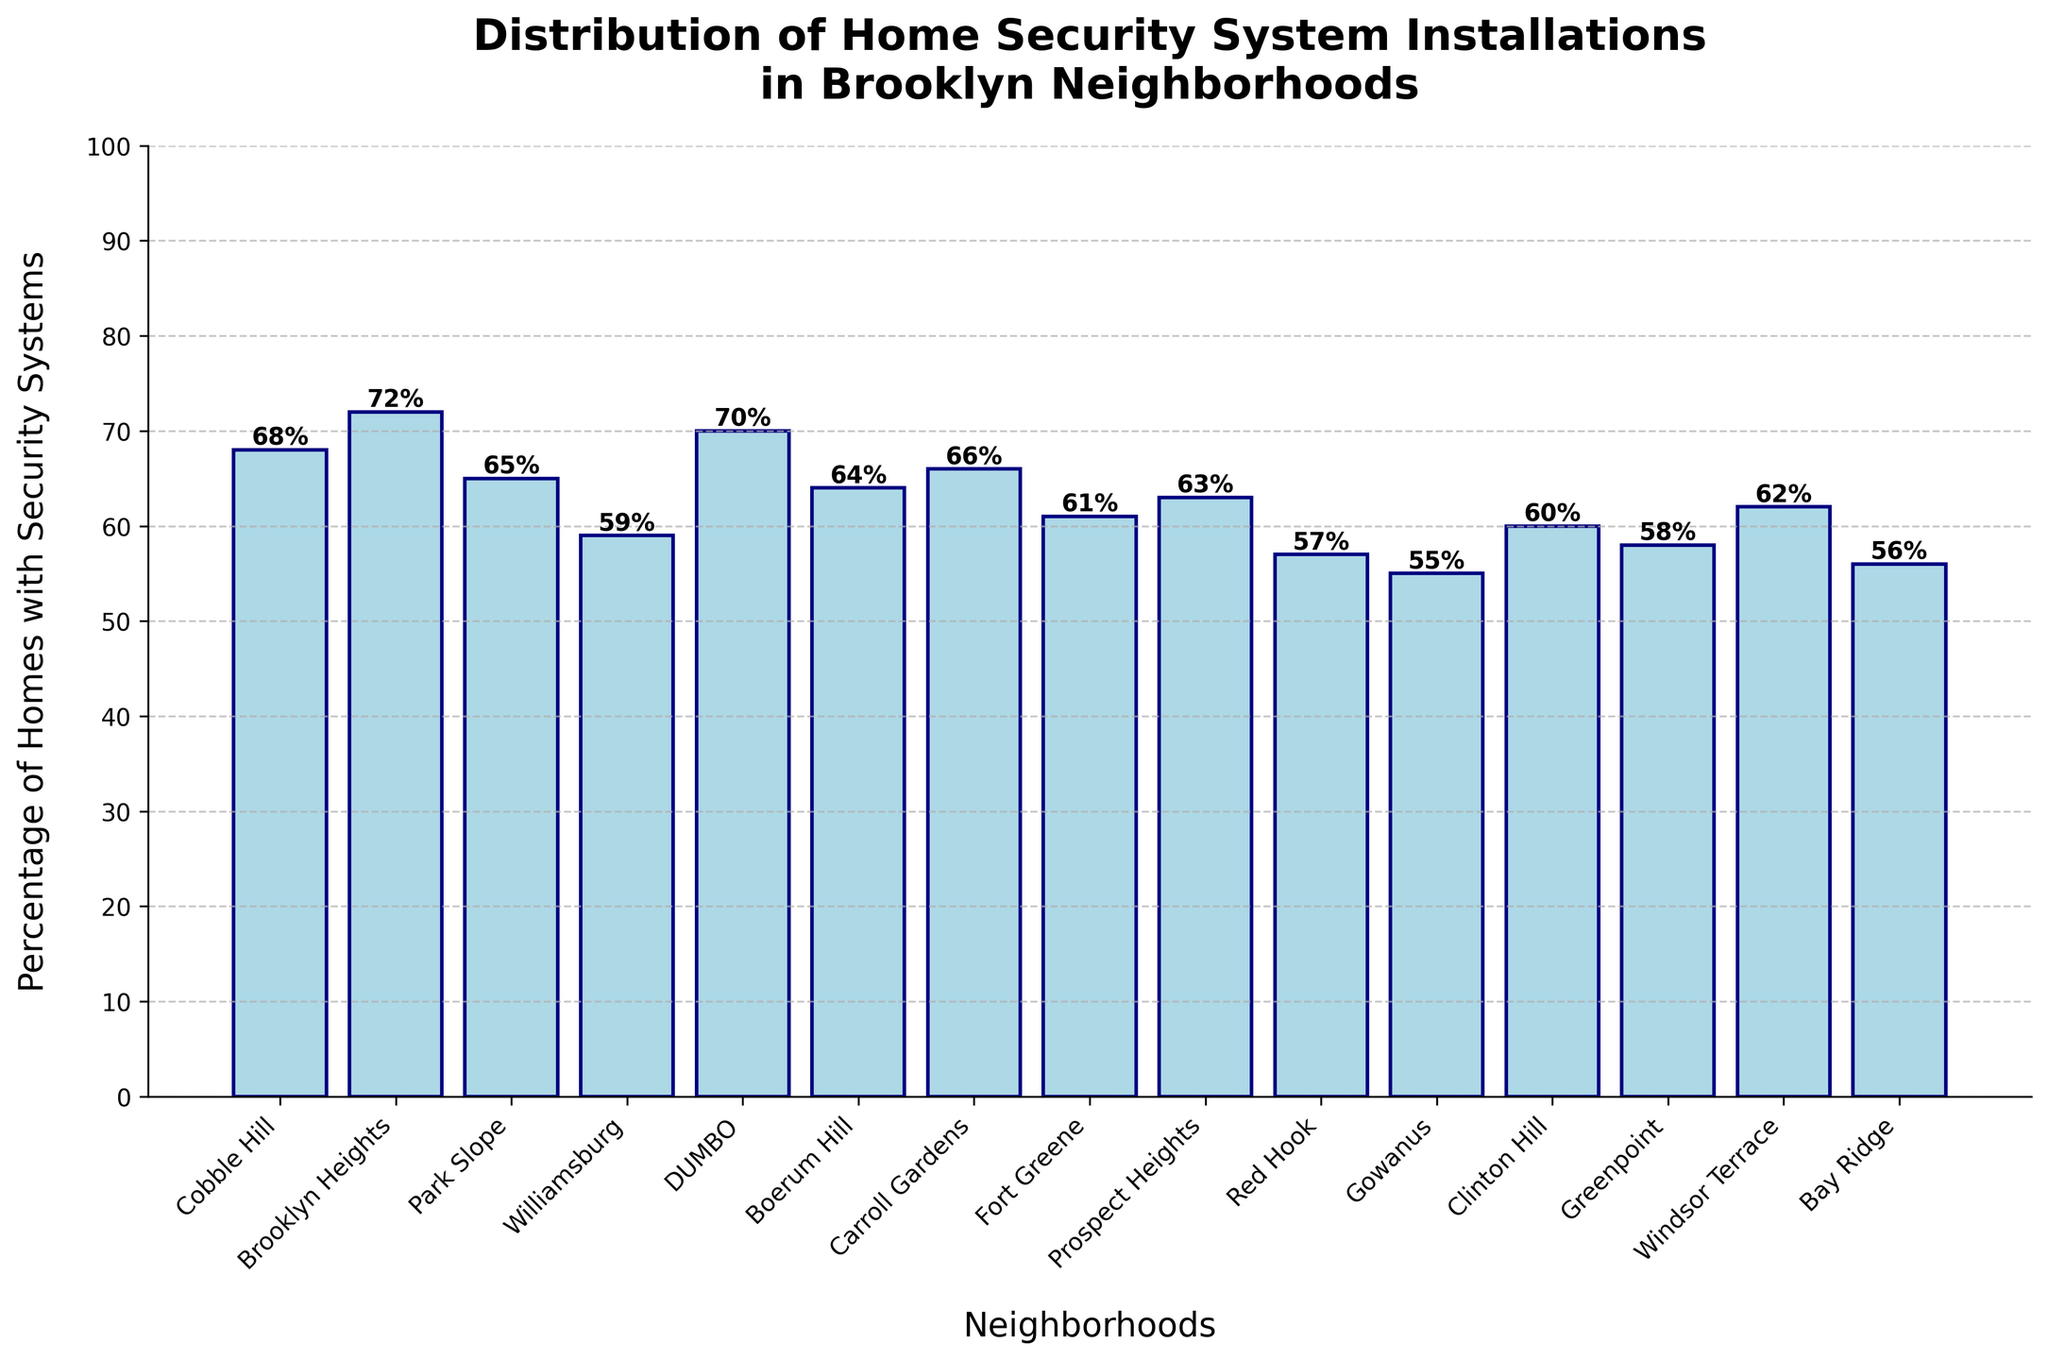How many more homes in Cobble Hill have security systems installed compared to Red Hook? Cobble Hill has 68% of homes with security systems while Red Hook has 57%. The difference is 68 - 57.
Answer: 11% Which neighborhood has the highest percentage of homes with security systems? By observing the heights of the bars, Brooklyn Heights has the highest percentage at 72%.
Answer: Brooklyn Heights What is the average percentage of homes with security systems in Carroll Gardens, Fort Greene, and Windsor Terrace? The percentage for each neighborhood is 66%, 61%, and 62%. The average is (66 + 61 + 62) / 3 = 63%.
Answer: 63% Is the percentage of homes with security systems in Gowanus greater than in Greenpoint? Gowanus has 55% and Greenpoint has 58% of homes with security systems. 55% is less than 58%.
Answer: No Which two neighborhoods have the lowest and highest percentage of home security systems installed? The lowest is Gowanus at 55%, and the highest is Brooklyn Heights at 72%.
Answer: Gowanus and Brooklyn Heights By how much does the percentage of homes with security systems in DUMBO exceed that in Williamsburg? DUMBO has 70%, and Williamsburg has 59%. The difference is 70 - 59.
Answer: 11% What is the total percentage of homes with security systems in Cobble Hill, Brooklyn Heights, and Park Slope combined? Cobble Hill has 68%, Brooklyn Heights 72%, and Park Slope 65%. The total is 68 + 72 + 65.
Answer: 205% Do the median percentages of homes with security systems for the neighborhoods shown fall above or below 65%? List the percentages: 55, 56, 57, 58, 59, 60, 61, 62, 63, 64, 65, 66, 68, 70, 72. The median is the 8th value which is 63.
Answer: Below 